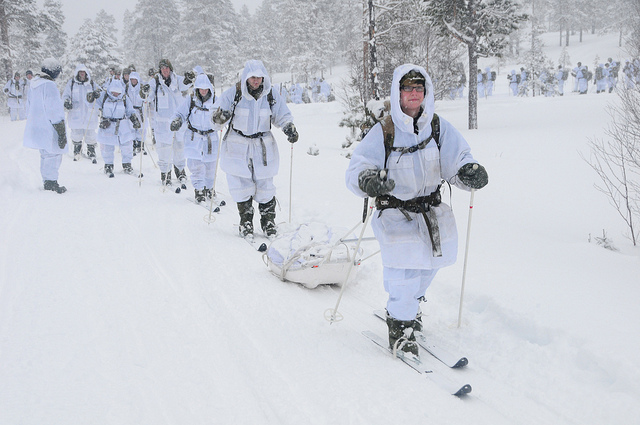<image>What child is wearing black pants? There is no child wearing black pants in the image. What child is wearing black pants? There is no child wearing black pants in the image. 